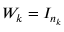Convert formula to latex. <formula><loc_0><loc_0><loc_500><loc_500>W _ { k } = I _ { n _ { k } }</formula> 